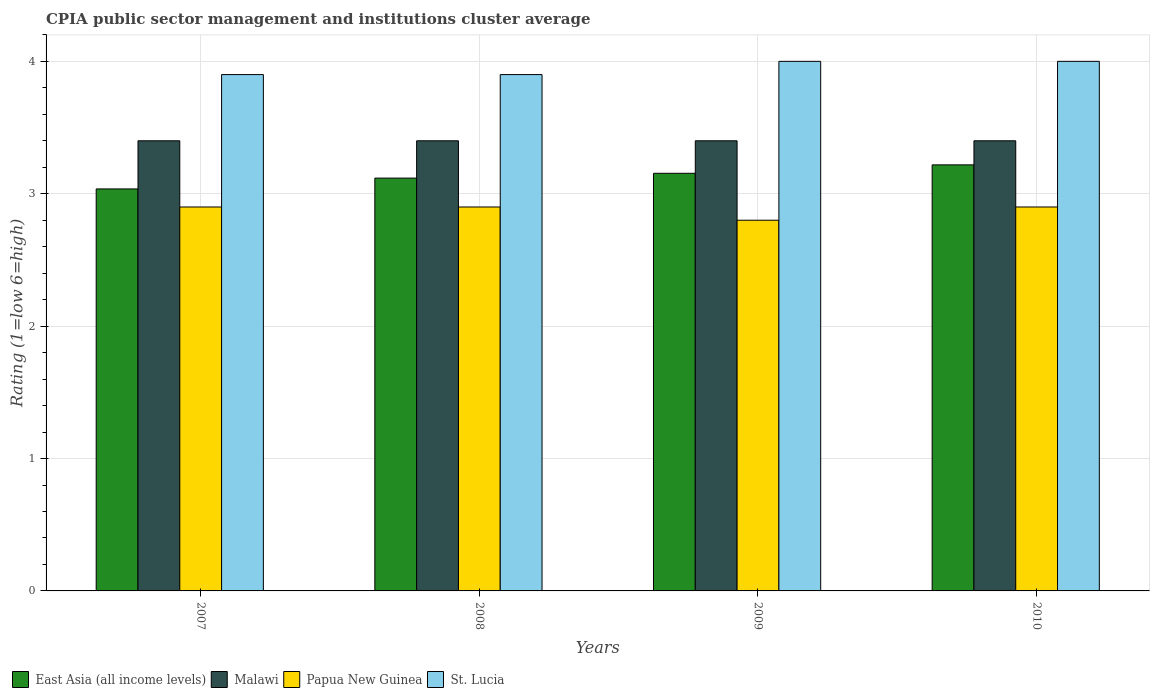How many different coloured bars are there?
Your answer should be very brief. 4. Are the number of bars on each tick of the X-axis equal?
Your answer should be compact. Yes. How many bars are there on the 4th tick from the left?
Offer a very short reply. 4. In how many cases, is the number of bars for a given year not equal to the number of legend labels?
Give a very brief answer. 0. What is the CPIA rating in Papua New Guinea in 2009?
Provide a short and direct response. 2.8. Across all years, what is the maximum CPIA rating in Papua New Guinea?
Ensure brevity in your answer.  2.9. What is the difference between the CPIA rating in St. Lucia in 2007 and that in 2008?
Keep it short and to the point. 0. What is the difference between the CPIA rating in East Asia (all income levels) in 2007 and the CPIA rating in Malawi in 2009?
Ensure brevity in your answer.  -0.36. What is the average CPIA rating in Papua New Guinea per year?
Offer a very short reply. 2.88. In the year 2008, what is the difference between the CPIA rating in East Asia (all income levels) and CPIA rating in Papua New Guinea?
Offer a very short reply. 0.22. Is the CPIA rating in Papua New Guinea in 2007 less than that in 2008?
Offer a very short reply. No. Is the difference between the CPIA rating in East Asia (all income levels) in 2009 and 2010 greater than the difference between the CPIA rating in Papua New Guinea in 2009 and 2010?
Offer a terse response. Yes. What is the difference between the highest and the lowest CPIA rating in East Asia (all income levels)?
Your answer should be compact. 0.18. In how many years, is the CPIA rating in St. Lucia greater than the average CPIA rating in St. Lucia taken over all years?
Keep it short and to the point. 2. What does the 4th bar from the left in 2010 represents?
Your answer should be compact. St. Lucia. What does the 4th bar from the right in 2009 represents?
Give a very brief answer. East Asia (all income levels). Is it the case that in every year, the sum of the CPIA rating in East Asia (all income levels) and CPIA rating in Papua New Guinea is greater than the CPIA rating in Malawi?
Your answer should be very brief. Yes. How many bars are there?
Your answer should be compact. 16. What is the difference between two consecutive major ticks on the Y-axis?
Keep it short and to the point. 1. Are the values on the major ticks of Y-axis written in scientific E-notation?
Ensure brevity in your answer.  No. Where does the legend appear in the graph?
Ensure brevity in your answer.  Bottom left. How many legend labels are there?
Your answer should be compact. 4. What is the title of the graph?
Ensure brevity in your answer.  CPIA public sector management and institutions cluster average. Does "Myanmar" appear as one of the legend labels in the graph?
Provide a short and direct response. No. What is the label or title of the X-axis?
Ensure brevity in your answer.  Years. What is the Rating (1=low 6=high) in East Asia (all income levels) in 2007?
Offer a very short reply. 3.04. What is the Rating (1=low 6=high) of Papua New Guinea in 2007?
Offer a terse response. 2.9. What is the Rating (1=low 6=high) of St. Lucia in 2007?
Keep it short and to the point. 3.9. What is the Rating (1=low 6=high) of East Asia (all income levels) in 2008?
Your answer should be compact. 3.12. What is the Rating (1=low 6=high) in East Asia (all income levels) in 2009?
Keep it short and to the point. 3.15. What is the Rating (1=low 6=high) of Malawi in 2009?
Your answer should be compact. 3.4. What is the Rating (1=low 6=high) of St. Lucia in 2009?
Keep it short and to the point. 4. What is the Rating (1=low 6=high) of East Asia (all income levels) in 2010?
Give a very brief answer. 3.22. What is the Rating (1=low 6=high) in Malawi in 2010?
Provide a short and direct response. 3.4. What is the Rating (1=low 6=high) of Papua New Guinea in 2010?
Your answer should be compact. 2.9. Across all years, what is the maximum Rating (1=low 6=high) in East Asia (all income levels)?
Ensure brevity in your answer.  3.22. Across all years, what is the maximum Rating (1=low 6=high) in St. Lucia?
Offer a terse response. 4. Across all years, what is the minimum Rating (1=low 6=high) of East Asia (all income levels)?
Provide a succinct answer. 3.04. Across all years, what is the minimum Rating (1=low 6=high) of St. Lucia?
Keep it short and to the point. 3.9. What is the total Rating (1=low 6=high) of East Asia (all income levels) in the graph?
Give a very brief answer. 12.53. What is the total Rating (1=low 6=high) in Malawi in the graph?
Your answer should be compact. 13.6. What is the total Rating (1=low 6=high) in St. Lucia in the graph?
Your response must be concise. 15.8. What is the difference between the Rating (1=low 6=high) of East Asia (all income levels) in 2007 and that in 2008?
Keep it short and to the point. -0.08. What is the difference between the Rating (1=low 6=high) of St. Lucia in 2007 and that in 2008?
Ensure brevity in your answer.  0. What is the difference between the Rating (1=low 6=high) in East Asia (all income levels) in 2007 and that in 2009?
Your answer should be compact. -0.12. What is the difference between the Rating (1=low 6=high) of St. Lucia in 2007 and that in 2009?
Your answer should be compact. -0.1. What is the difference between the Rating (1=low 6=high) in East Asia (all income levels) in 2007 and that in 2010?
Keep it short and to the point. -0.18. What is the difference between the Rating (1=low 6=high) in Papua New Guinea in 2007 and that in 2010?
Offer a very short reply. 0. What is the difference between the Rating (1=low 6=high) of East Asia (all income levels) in 2008 and that in 2009?
Your answer should be compact. -0.04. What is the difference between the Rating (1=low 6=high) in Malawi in 2008 and that in 2009?
Offer a very short reply. 0. What is the difference between the Rating (1=low 6=high) in East Asia (all income levels) in 2008 and that in 2010?
Provide a succinct answer. -0.1. What is the difference between the Rating (1=low 6=high) in Malawi in 2008 and that in 2010?
Offer a very short reply. 0. What is the difference between the Rating (1=low 6=high) of East Asia (all income levels) in 2009 and that in 2010?
Give a very brief answer. -0.06. What is the difference between the Rating (1=low 6=high) in Malawi in 2009 and that in 2010?
Keep it short and to the point. 0. What is the difference between the Rating (1=low 6=high) of St. Lucia in 2009 and that in 2010?
Ensure brevity in your answer.  0. What is the difference between the Rating (1=low 6=high) of East Asia (all income levels) in 2007 and the Rating (1=low 6=high) of Malawi in 2008?
Your answer should be very brief. -0.36. What is the difference between the Rating (1=low 6=high) in East Asia (all income levels) in 2007 and the Rating (1=low 6=high) in Papua New Guinea in 2008?
Give a very brief answer. 0.14. What is the difference between the Rating (1=low 6=high) in East Asia (all income levels) in 2007 and the Rating (1=low 6=high) in St. Lucia in 2008?
Your answer should be compact. -0.86. What is the difference between the Rating (1=low 6=high) in Malawi in 2007 and the Rating (1=low 6=high) in Papua New Guinea in 2008?
Ensure brevity in your answer.  0.5. What is the difference between the Rating (1=low 6=high) in Malawi in 2007 and the Rating (1=low 6=high) in St. Lucia in 2008?
Your response must be concise. -0.5. What is the difference between the Rating (1=low 6=high) of Papua New Guinea in 2007 and the Rating (1=low 6=high) of St. Lucia in 2008?
Offer a terse response. -1. What is the difference between the Rating (1=low 6=high) in East Asia (all income levels) in 2007 and the Rating (1=low 6=high) in Malawi in 2009?
Your answer should be very brief. -0.36. What is the difference between the Rating (1=low 6=high) in East Asia (all income levels) in 2007 and the Rating (1=low 6=high) in Papua New Guinea in 2009?
Give a very brief answer. 0.24. What is the difference between the Rating (1=low 6=high) of East Asia (all income levels) in 2007 and the Rating (1=low 6=high) of St. Lucia in 2009?
Offer a very short reply. -0.96. What is the difference between the Rating (1=low 6=high) of Malawi in 2007 and the Rating (1=low 6=high) of St. Lucia in 2009?
Ensure brevity in your answer.  -0.6. What is the difference between the Rating (1=low 6=high) in East Asia (all income levels) in 2007 and the Rating (1=low 6=high) in Malawi in 2010?
Your answer should be very brief. -0.36. What is the difference between the Rating (1=low 6=high) of East Asia (all income levels) in 2007 and the Rating (1=low 6=high) of Papua New Guinea in 2010?
Keep it short and to the point. 0.14. What is the difference between the Rating (1=low 6=high) in East Asia (all income levels) in 2007 and the Rating (1=low 6=high) in St. Lucia in 2010?
Make the answer very short. -0.96. What is the difference between the Rating (1=low 6=high) of Malawi in 2007 and the Rating (1=low 6=high) of Papua New Guinea in 2010?
Your response must be concise. 0.5. What is the difference between the Rating (1=low 6=high) in East Asia (all income levels) in 2008 and the Rating (1=low 6=high) in Malawi in 2009?
Your answer should be very brief. -0.28. What is the difference between the Rating (1=low 6=high) of East Asia (all income levels) in 2008 and the Rating (1=low 6=high) of Papua New Guinea in 2009?
Make the answer very short. 0.32. What is the difference between the Rating (1=low 6=high) of East Asia (all income levels) in 2008 and the Rating (1=low 6=high) of St. Lucia in 2009?
Give a very brief answer. -0.88. What is the difference between the Rating (1=low 6=high) of Malawi in 2008 and the Rating (1=low 6=high) of Papua New Guinea in 2009?
Give a very brief answer. 0.6. What is the difference between the Rating (1=low 6=high) in Malawi in 2008 and the Rating (1=low 6=high) in St. Lucia in 2009?
Give a very brief answer. -0.6. What is the difference between the Rating (1=low 6=high) in East Asia (all income levels) in 2008 and the Rating (1=low 6=high) in Malawi in 2010?
Provide a short and direct response. -0.28. What is the difference between the Rating (1=low 6=high) in East Asia (all income levels) in 2008 and the Rating (1=low 6=high) in Papua New Guinea in 2010?
Keep it short and to the point. 0.22. What is the difference between the Rating (1=low 6=high) in East Asia (all income levels) in 2008 and the Rating (1=low 6=high) in St. Lucia in 2010?
Keep it short and to the point. -0.88. What is the difference between the Rating (1=low 6=high) in Malawi in 2008 and the Rating (1=low 6=high) in St. Lucia in 2010?
Your answer should be very brief. -0.6. What is the difference between the Rating (1=low 6=high) in East Asia (all income levels) in 2009 and the Rating (1=low 6=high) in Malawi in 2010?
Your response must be concise. -0.25. What is the difference between the Rating (1=low 6=high) of East Asia (all income levels) in 2009 and the Rating (1=low 6=high) of Papua New Guinea in 2010?
Your response must be concise. 0.25. What is the difference between the Rating (1=low 6=high) of East Asia (all income levels) in 2009 and the Rating (1=low 6=high) of St. Lucia in 2010?
Give a very brief answer. -0.85. What is the difference between the Rating (1=low 6=high) in Malawi in 2009 and the Rating (1=low 6=high) in St. Lucia in 2010?
Offer a terse response. -0.6. What is the difference between the Rating (1=low 6=high) of Papua New Guinea in 2009 and the Rating (1=low 6=high) of St. Lucia in 2010?
Offer a very short reply. -1.2. What is the average Rating (1=low 6=high) in East Asia (all income levels) per year?
Provide a succinct answer. 3.13. What is the average Rating (1=low 6=high) of Papua New Guinea per year?
Your response must be concise. 2.88. What is the average Rating (1=low 6=high) of St. Lucia per year?
Ensure brevity in your answer.  3.95. In the year 2007, what is the difference between the Rating (1=low 6=high) of East Asia (all income levels) and Rating (1=low 6=high) of Malawi?
Provide a short and direct response. -0.36. In the year 2007, what is the difference between the Rating (1=low 6=high) of East Asia (all income levels) and Rating (1=low 6=high) of Papua New Guinea?
Ensure brevity in your answer.  0.14. In the year 2007, what is the difference between the Rating (1=low 6=high) of East Asia (all income levels) and Rating (1=low 6=high) of St. Lucia?
Your answer should be compact. -0.86. In the year 2007, what is the difference between the Rating (1=low 6=high) in Malawi and Rating (1=low 6=high) in Papua New Guinea?
Your response must be concise. 0.5. In the year 2007, what is the difference between the Rating (1=low 6=high) of Papua New Guinea and Rating (1=low 6=high) of St. Lucia?
Provide a short and direct response. -1. In the year 2008, what is the difference between the Rating (1=low 6=high) in East Asia (all income levels) and Rating (1=low 6=high) in Malawi?
Offer a terse response. -0.28. In the year 2008, what is the difference between the Rating (1=low 6=high) in East Asia (all income levels) and Rating (1=low 6=high) in Papua New Guinea?
Your answer should be very brief. 0.22. In the year 2008, what is the difference between the Rating (1=low 6=high) in East Asia (all income levels) and Rating (1=low 6=high) in St. Lucia?
Your answer should be compact. -0.78. In the year 2008, what is the difference between the Rating (1=low 6=high) in Malawi and Rating (1=low 6=high) in Papua New Guinea?
Your answer should be very brief. 0.5. In the year 2008, what is the difference between the Rating (1=low 6=high) in Malawi and Rating (1=low 6=high) in St. Lucia?
Offer a very short reply. -0.5. In the year 2008, what is the difference between the Rating (1=low 6=high) in Papua New Guinea and Rating (1=low 6=high) in St. Lucia?
Your answer should be compact. -1. In the year 2009, what is the difference between the Rating (1=low 6=high) of East Asia (all income levels) and Rating (1=low 6=high) of Malawi?
Your answer should be very brief. -0.25. In the year 2009, what is the difference between the Rating (1=low 6=high) in East Asia (all income levels) and Rating (1=low 6=high) in Papua New Guinea?
Keep it short and to the point. 0.35. In the year 2009, what is the difference between the Rating (1=low 6=high) of East Asia (all income levels) and Rating (1=low 6=high) of St. Lucia?
Offer a terse response. -0.85. In the year 2009, what is the difference between the Rating (1=low 6=high) of Papua New Guinea and Rating (1=low 6=high) of St. Lucia?
Offer a very short reply. -1.2. In the year 2010, what is the difference between the Rating (1=low 6=high) of East Asia (all income levels) and Rating (1=low 6=high) of Malawi?
Give a very brief answer. -0.18. In the year 2010, what is the difference between the Rating (1=low 6=high) of East Asia (all income levels) and Rating (1=low 6=high) of Papua New Guinea?
Provide a succinct answer. 0.32. In the year 2010, what is the difference between the Rating (1=low 6=high) of East Asia (all income levels) and Rating (1=low 6=high) of St. Lucia?
Offer a terse response. -0.78. In the year 2010, what is the difference between the Rating (1=low 6=high) of Papua New Guinea and Rating (1=low 6=high) of St. Lucia?
Offer a terse response. -1.1. What is the ratio of the Rating (1=low 6=high) in East Asia (all income levels) in 2007 to that in 2008?
Ensure brevity in your answer.  0.97. What is the ratio of the Rating (1=low 6=high) of Papua New Guinea in 2007 to that in 2008?
Offer a very short reply. 1. What is the ratio of the Rating (1=low 6=high) in East Asia (all income levels) in 2007 to that in 2009?
Keep it short and to the point. 0.96. What is the ratio of the Rating (1=low 6=high) of Papua New Guinea in 2007 to that in 2009?
Offer a terse response. 1.04. What is the ratio of the Rating (1=low 6=high) of St. Lucia in 2007 to that in 2009?
Your answer should be very brief. 0.97. What is the ratio of the Rating (1=low 6=high) of East Asia (all income levels) in 2007 to that in 2010?
Keep it short and to the point. 0.94. What is the ratio of the Rating (1=low 6=high) of St. Lucia in 2007 to that in 2010?
Ensure brevity in your answer.  0.97. What is the ratio of the Rating (1=low 6=high) of Papua New Guinea in 2008 to that in 2009?
Give a very brief answer. 1.04. What is the ratio of the Rating (1=low 6=high) in East Asia (all income levels) in 2008 to that in 2010?
Your response must be concise. 0.97. What is the ratio of the Rating (1=low 6=high) of Malawi in 2008 to that in 2010?
Your answer should be very brief. 1. What is the ratio of the Rating (1=low 6=high) of Papua New Guinea in 2008 to that in 2010?
Give a very brief answer. 1. What is the ratio of the Rating (1=low 6=high) of St. Lucia in 2008 to that in 2010?
Provide a short and direct response. 0.97. What is the ratio of the Rating (1=low 6=high) of East Asia (all income levels) in 2009 to that in 2010?
Provide a short and direct response. 0.98. What is the ratio of the Rating (1=low 6=high) of Papua New Guinea in 2009 to that in 2010?
Provide a succinct answer. 0.97. What is the difference between the highest and the second highest Rating (1=low 6=high) of East Asia (all income levels)?
Your answer should be compact. 0.06. What is the difference between the highest and the second highest Rating (1=low 6=high) in Malawi?
Ensure brevity in your answer.  0. What is the difference between the highest and the second highest Rating (1=low 6=high) of Papua New Guinea?
Offer a very short reply. 0. What is the difference between the highest and the lowest Rating (1=low 6=high) in East Asia (all income levels)?
Your response must be concise. 0.18. What is the difference between the highest and the lowest Rating (1=low 6=high) of Malawi?
Your answer should be compact. 0. What is the difference between the highest and the lowest Rating (1=low 6=high) of Papua New Guinea?
Your answer should be very brief. 0.1. What is the difference between the highest and the lowest Rating (1=low 6=high) in St. Lucia?
Make the answer very short. 0.1. 